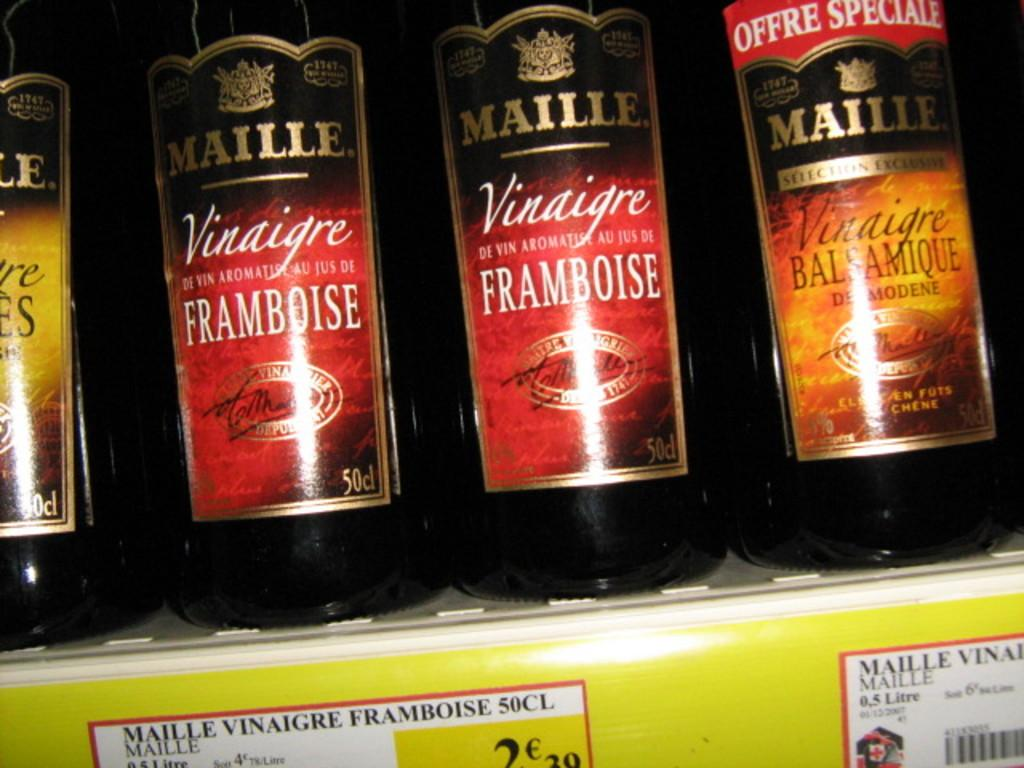<image>
Provide a brief description of the given image. Bottles of Maille are lined up in a row. 